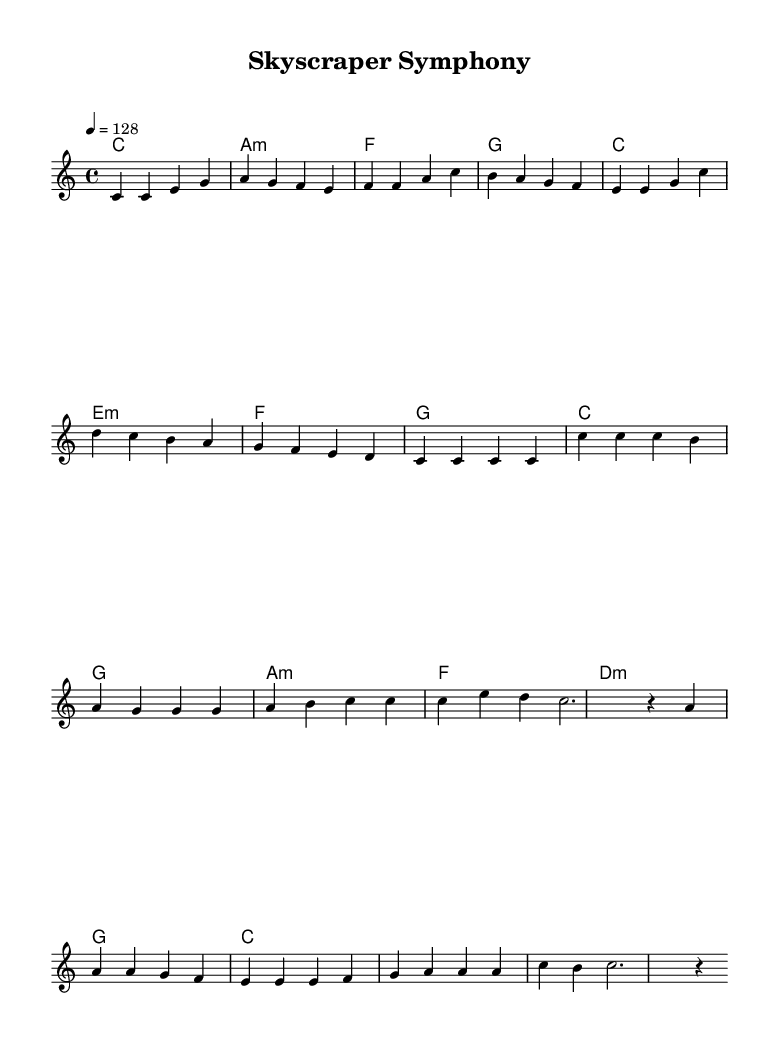What is the key signature of this music? The key signature is C major, which has no sharps or flats visually represented on the staff at the beginning of the piece.
Answer: C major What is the time signature of this music? The time signature is indicated as 4/4, meaning there are four beats per measure and the quarter note receives one beat. This is found at the beginning of the music.
Answer: 4/4 What is the tempo marking for this piece? The tempo marking shows that the piece should be played at 128 beats per minute, which is indicated at the start of the score.
Answer: 128 How many measures are in the verse section? The verse section consists of eight measures, counted by the number of vertical lines (bar lines) that separate the measure notes.
Answer: 8 Which chord appears in the chorus after the A minor chord? The chord that appears right after the A minor chord in the chorus is F major, listed in the chord symbols above the staff.
Answer: F In what musical mode is this piece primarily written? The piece is primarily written in a major mode, indicated by the use of a C major key signature and the upbeat nature of the melodies.
Answer: Major What is the first note of the melody? The first note of the melody is a C, as it appears at the beginning of the melody line.
Answer: C 